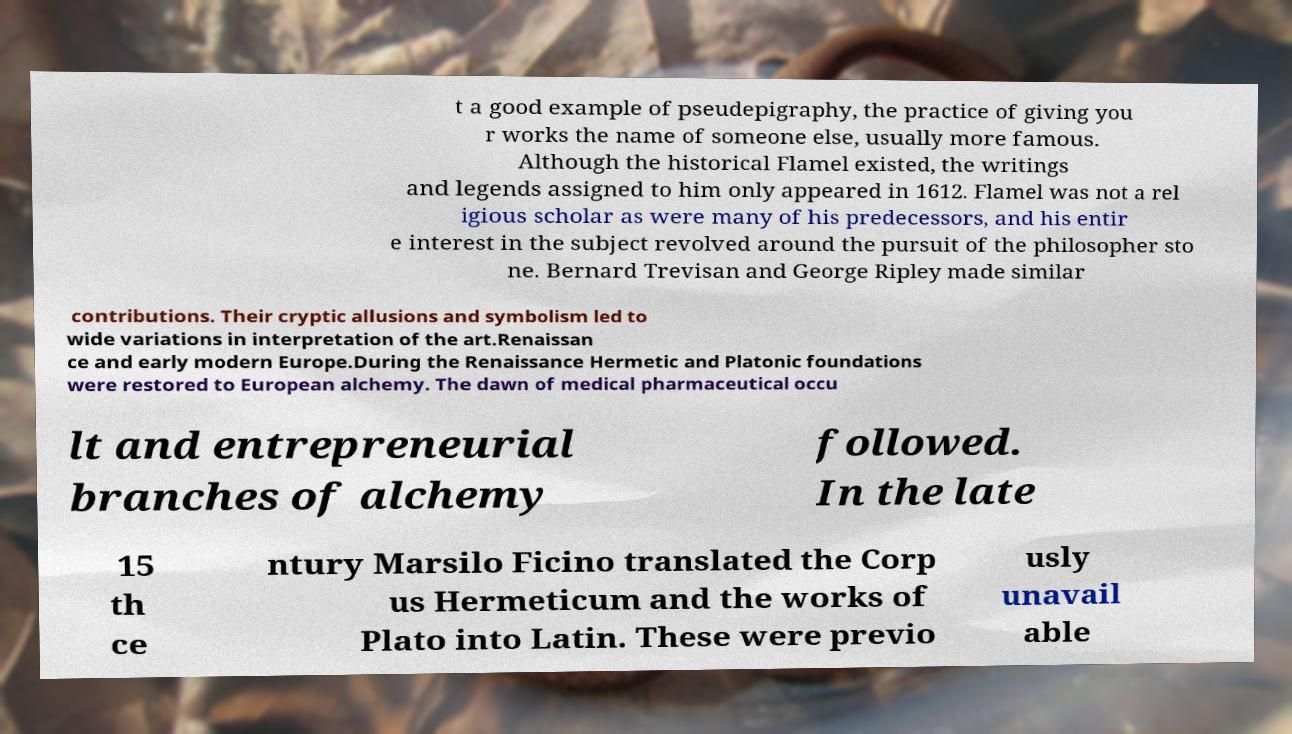Could you extract and type out the text from this image? t a good example of pseudepigraphy, the practice of giving you r works the name of someone else, usually more famous. Although the historical Flamel existed, the writings and legends assigned to him only appeared in 1612. Flamel was not a rel igious scholar as were many of his predecessors, and his entir e interest in the subject revolved around the pursuit of the philosopher sto ne. Bernard Trevisan and George Ripley made similar contributions. Their cryptic allusions and symbolism led to wide variations in interpretation of the art.Renaissan ce and early modern Europe.During the Renaissance Hermetic and Platonic foundations were restored to European alchemy. The dawn of medical pharmaceutical occu lt and entrepreneurial branches of alchemy followed. In the late 15 th ce ntury Marsilo Ficino translated the Corp us Hermeticum and the works of Plato into Latin. These were previo usly unavail able 